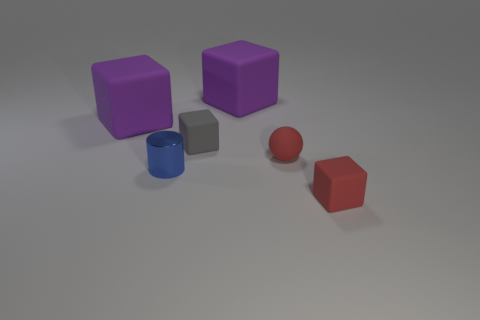There is a object that is both in front of the small red rubber sphere and to the right of the tiny blue cylinder; what is its size?
Keep it short and to the point. Small. There is a small metal cylinder; is its color the same as the tiny block that is behind the red rubber block?
Your answer should be compact. No. Are there any big cyan rubber things that have the same shape as the gray matte object?
Offer a terse response. No. What number of things are tiny red matte things or purple rubber cubes that are on the left side of the blue shiny object?
Offer a terse response. 3. How many other things are made of the same material as the small sphere?
Your answer should be compact. 4. How many things are cylinders or spheres?
Ensure brevity in your answer.  2. Is the number of small things that are right of the small blue shiny cylinder greater than the number of tiny rubber balls on the left side of the small gray matte block?
Your answer should be very brief. Yes. Do the big rubber thing on the left side of the tiny gray rubber cube and the big object on the right side of the gray rubber cube have the same color?
Keep it short and to the point. Yes. What is the size of the block behind the purple rubber object on the left side of the small rubber cube behind the blue metal cylinder?
Provide a succinct answer. Large. What is the color of the other small rubber object that is the same shape as the small gray object?
Ensure brevity in your answer.  Red. 